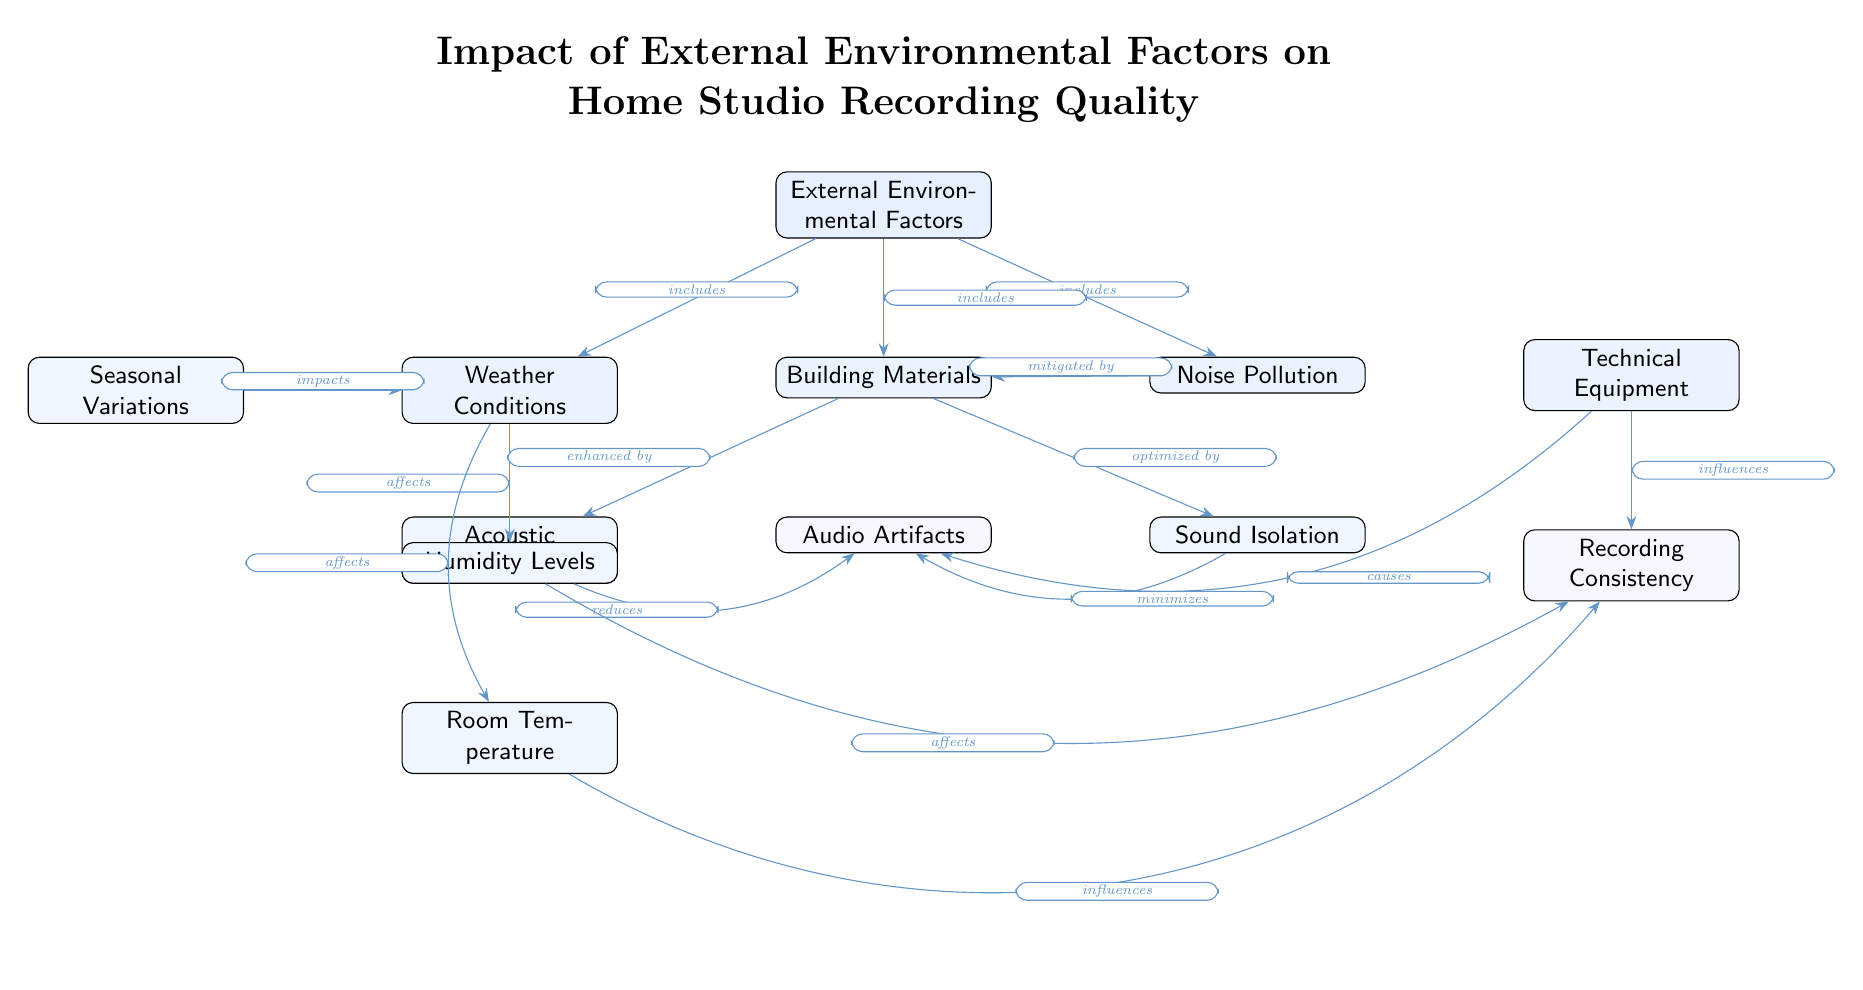What are the main categories of External Environmental Factors? The diagram lists three main categories of external environmental factors: Weather Conditions, Noise Pollution, and Building Materials. These categories are visible directly connected to the main node labeled "External Environmental Factors."
Answer: Weather Conditions, Noise Pollution, Building Materials How many nodes are present in the diagram? By counting each distinct entity represented in the diagram, we see a total of 12 nodes. This includes both main nodes and sub-nodes that represent various factors.
Answer: 12 Which factor impacts Room Temperature? The diagram indicates that Humidity Levels affect Room Temperature, as denoted by the arrow leading from Humidity Levels to Room Temperature.
Answer: Humidity Levels What does Acoustic Treatment enhance? There is an arrow pointing from Acoustic Treatment to Audio Artifacts, indicating that Acoustic Treatment enhances Audio Artifacts as portrayed in the relationship.
Answer: Audio Artifacts Which external environmental factor is mitigated by Building Materials? The diagram shows that Noise Pollution is mitigated by Building Materials, as evidenced by the arrow connecting the two nodes with the label indicating this relationship.
Answer: Noise Pollution What is influenced by Technical Equipment and Humidity Levels? Based on the edges in the diagram, both Technical Equipment and Humidity Levels influence Recording Consistency, since arrows from both nodes reach Recording Consistency.
Answer: Recording Consistency How many edges connect to the node Building Materials? Counting the edges leading to and from Building Materials, we find it has four edges connecting to other nodes, revealing its interactions in the context of the diagram.
Answer: 4 Which two factors reduce Audio Artifacts? Both Acoustic Treatment and Sound Isolation are indicated by arrows leading away from them to Audio Artifacts, meaning they reduce Audio Artifacts as described in the relationships.
Answer: Acoustic Treatment, Sound Isolation 